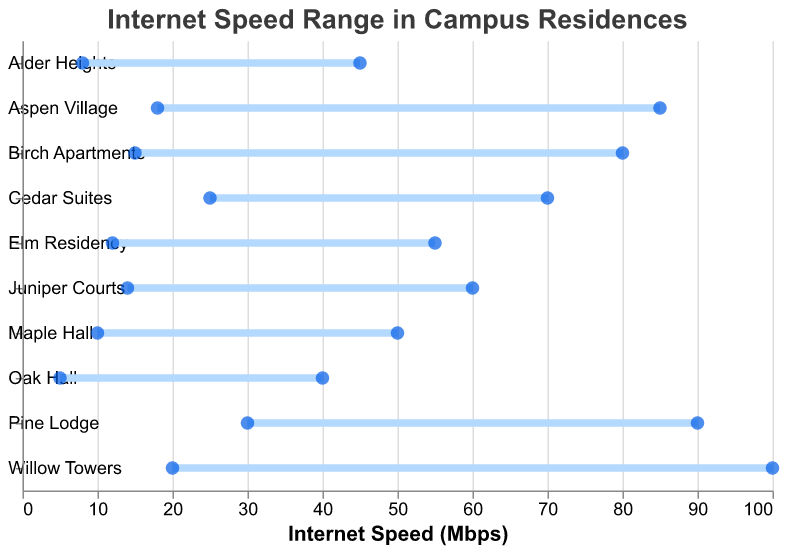What is the range of speeds for Willow Towers? The plot shows the minimum speed at 20 Mbps and the maximum speed at 100 Mbps for Willow Towers.
Answer: 20-100 Mbps Which residence has the lowest minimum internet speed? The plot shows Oak Hall has the lowest minimum speed at 5 Mbps.
Answer: Oak Hall Which residence has the highest maximum internet speed? The plot shows Willow Towers has the highest maximum speed at 100 Mbps.
Answer: Willow Towers What is the average maximum internet speed across all residences? Summing up the maximum speeds (50+40+80+100+70+90+55+45+85+60) gives a total of 675. Dividing by the number of residences (10) results in an average of 67.5 Mbps.
Answer: 67.5 Mbps What is the difference in the internet speed range between Oak Hall and Pine Lodge? Oak Hall's range is 5-40 (35 Mbps) and Pine Lodge's range is 30-90 (60 Mbps). The difference in range is 60 - 35 = 25 Mbps.
Answer: 25 Mbps Which residence has a wider range of internet speeds, Birch Apartments or Cedar Suites? Birch Apartments has a range of 15-80 (65 Mbps) and Cedar Suites has a range of 25-70 (45 Mbps). Birch Apartments has the wider range.
Answer: Birch Apartments Which residence has the closest maximum speed to 60 Mbps? Juniper Courts has a maximum speed of 60 Mbps, which is exactly 60 Mbps.
Answer: Juniper Courts How many residences have a minimum internet speed above 20 Mbps? The plot shows that Cedar Suites, Pine Lodge; Aspen Village each have a minimum speed at or above 20 Mbps. This gives a total of 3 residences.
Answer: 3 What is the median minimum internet speed across all residences? Listing the minimum speeds (5, 8, 10, 12, 14, 15, 18, 20, 25, 30) and finding the median of the dataset (14+15)/2 = 14.5 Mbps.
Answer: 14.5 Mbps Which residence has the largest difference between its minimum and maximum internet speeds? Willow Towers has a minimum speed of 20 Mbps and a maximum speed of 100 Mbps, a difference of 80 Mbps, largest of all the residences in the plot.
Answer: Willow Towers 